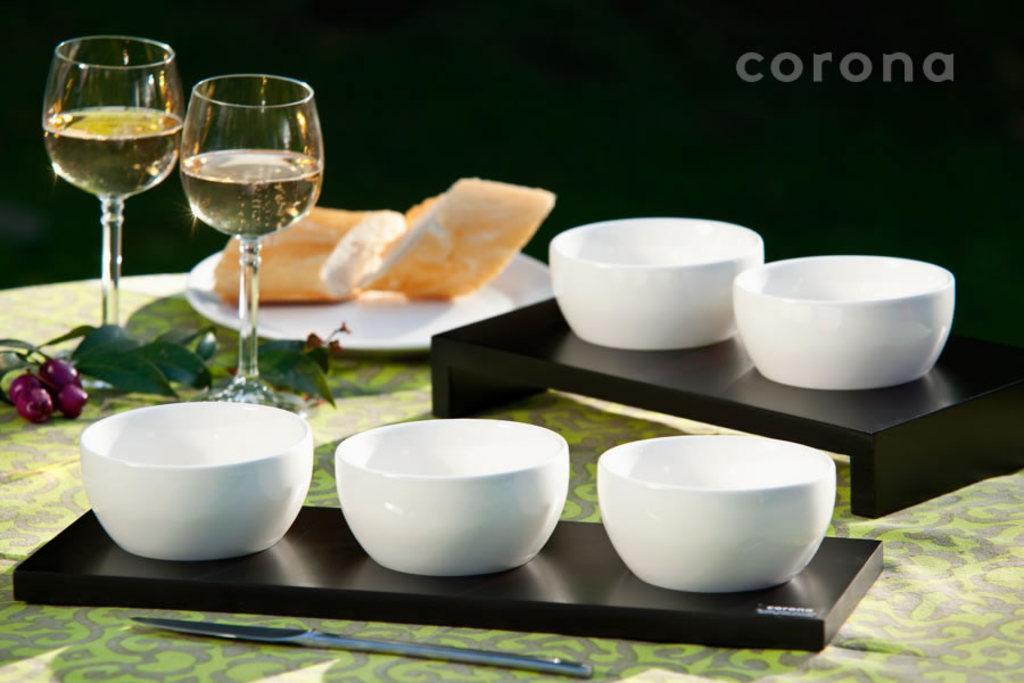Could you give a brief overview of what you see in this image? In this image we can see a few bowls placed on the wooden objects. There is some food on a plate and there are two glasses with drink. On the left side we can see few fruits on a cloth. At the bottom we can see a knife on a cloth. 